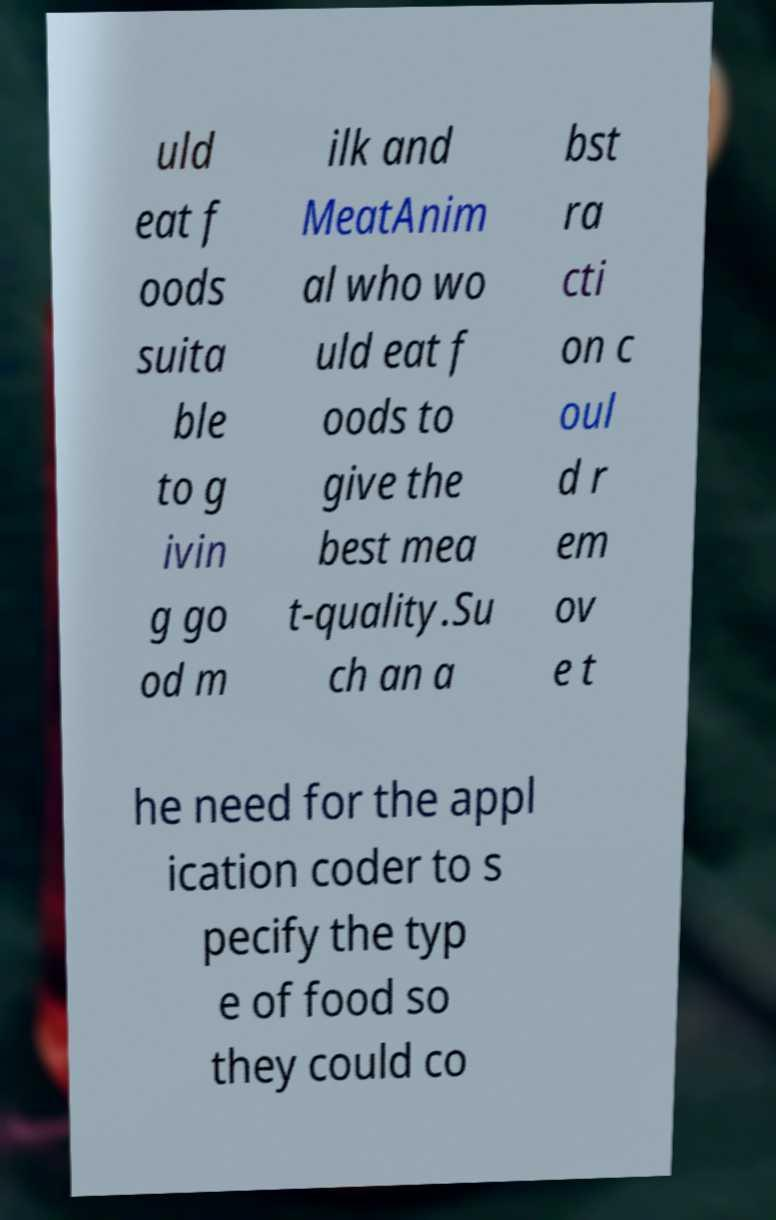What messages or text are displayed in this image? I need them in a readable, typed format. uld eat f oods suita ble to g ivin g go od m ilk and MeatAnim al who wo uld eat f oods to give the best mea t-quality.Su ch an a bst ra cti on c oul d r em ov e t he need for the appl ication coder to s pecify the typ e of food so they could co 